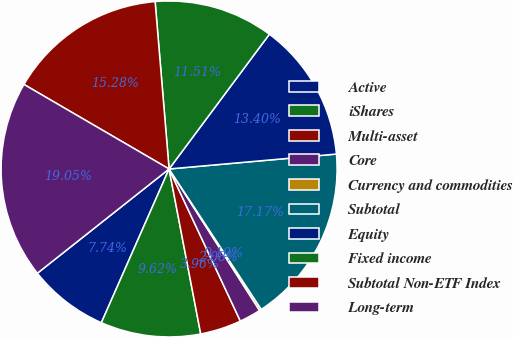<chart> <loc_0><loc_0><loc_500><loc_500><pie_chart><fcel>Active<fcel>iShares<fcel>Multi-asset<fcel>Core<fcel>Currency and commodities<fcel>Subtotal<fcel>Equity<fcel>Fixed income<fcel>Subtotal Non-ETF Index<fcel>Long-term<nl><fcel>7.74%<fcel>9.62%<fcel>3.96%<fcel>2.08%<fcel>0.19%<fcel>17.17%<fcel>13.4%<fcel>11.51%<fcel>15.28%<fcel>19.05%<nl></chart> 